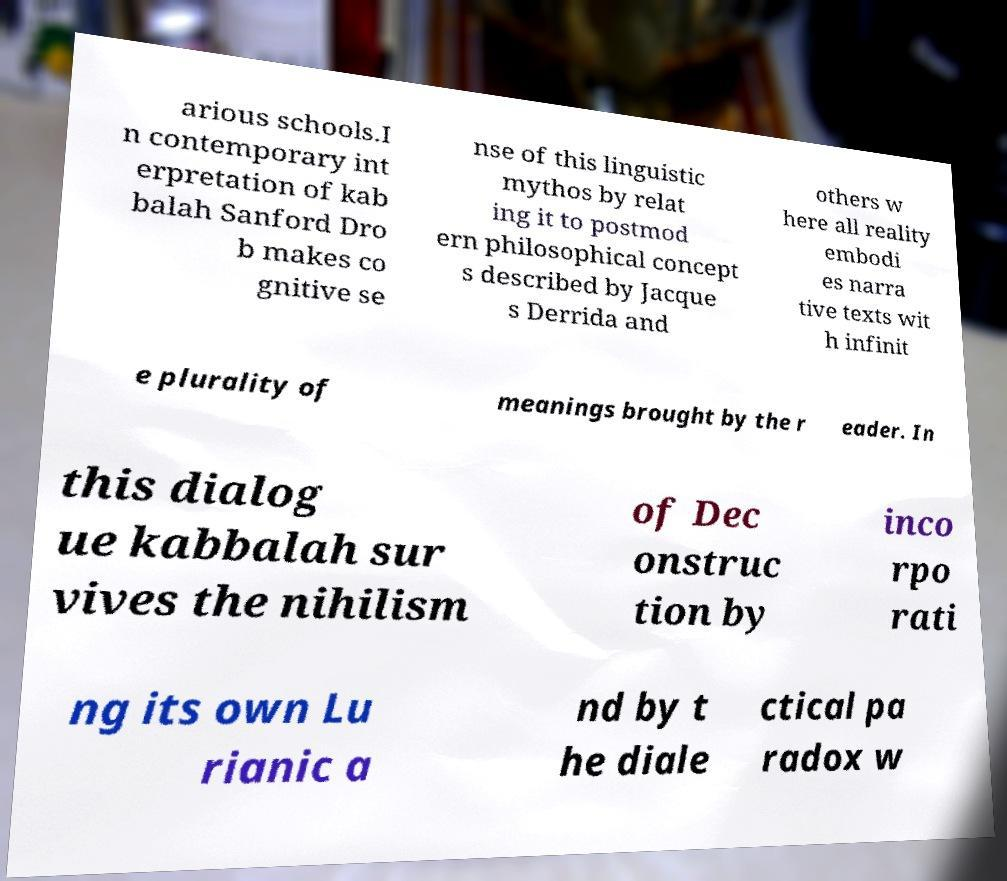For documentation purposes, I need the text within this image transcribed. Could you provide that? arious schools.I n contemporary int erpretation of kab balah Sanford Dro b makes co gnitive se nse of this linguistic mythos by relat ing it to postmod ern philosophical concept s described by Jacque s Derrida and others w here all reality embodi es narra tive texts wit h infinit e plurality of meanings brought by the r eader. In this dialog ue kabbalah sur vives the nihilism of Dec onstruc tion by inco rpo rati ng its own Lu rianic a nd by t he diale ctical pa radox w 